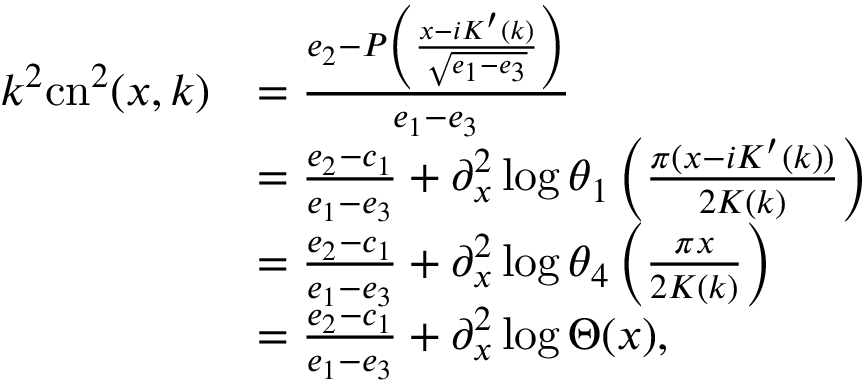Convert formula to latex. <formula><loc_0><loc_0><loc_500><loc_500>\begin{array} { r l } { k ^ { 2 } c n ^ { 2 } ( x , k ) } & { = \frac { e _ { 2 } - P \left ( \frac { x - i K ^ { \prime } ( k ) } { \sqrt { e _ { 1 } - e _ { 3 } } } \right ) } { e _ { 1 } - e _ { 3 } } } \\ & { = \frac { e _ { 2 } - c _ { 1 } } { e _ { 1 } - e _ { 3 } } + \partial _ { x } ^ { 2 } \log \theta _ { 1 } \left ( \frac { \pi ( x - i K ^ { \prime } ( k ) ) } { 2 K ( k ) } \right ) } \\ & { = \frac { e _ { 2 } - c _ { 1 } } { e _ { 1 } - e _ { 3 } } + \partial _ { x } ^ { 2 } \log \theta _ { 4 } \left ( \frac { \pi x } { 2 K ( k ) } \right ) } \\ & { = \frac { e _ { 2 } - c _ { 1 } } { e _ { 1 } - e _ { 3 } } + \partial _ { x } ^ { 2 } \log \Theta ( x ) , } \end{array}</formula> 